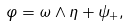<formula> <loc_0><loc_0><loc_500><loc_500>\varphi = \omega \wedge \eta + \psi _ { + } ,</formula> 